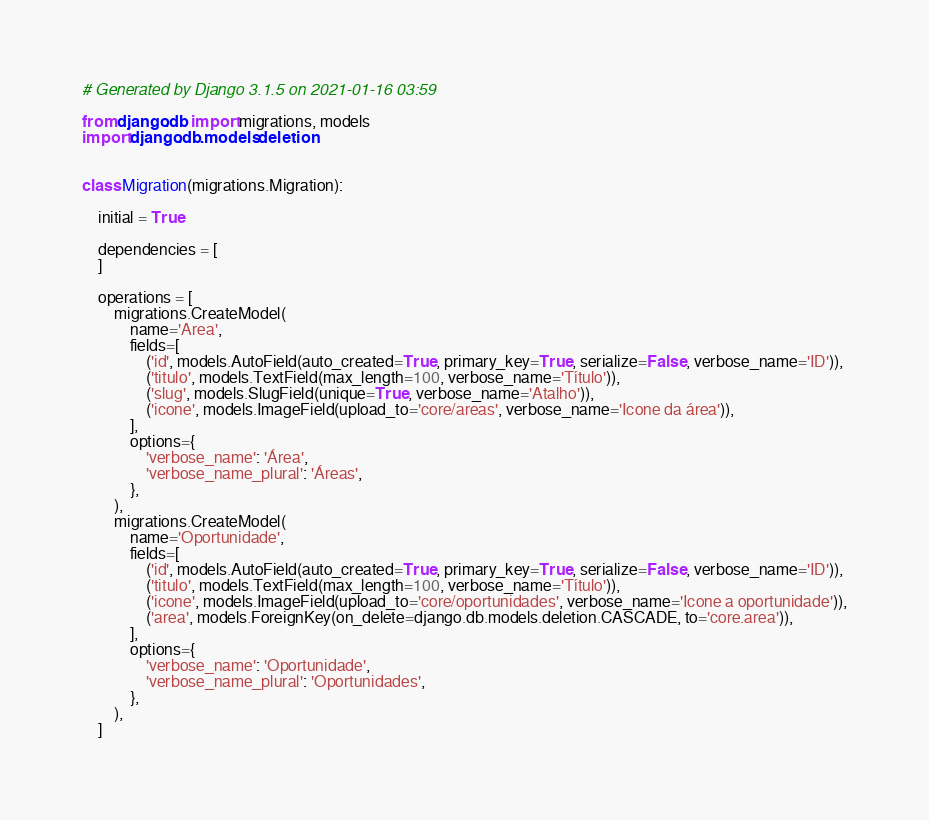<code> <loc_0><loc_0><loc_500><loc_500><_Python_># Generated by Django 3.1.5 on 2021-01-16 03:59

from django.db import migrations, models
import django.db.models.deletion


class Migration(migrations.Migration):

    initial = True

    dependencies = [
    ]

    operations = [
        migrations.CreateModel(
            name='Area',
            fields=[
                ('id', models.AutoField(auto_created=True, primary_key=True, serialize=False, verbose_name='ID')),
                ('titulo', models.TextField(max_length=100, verbose_name='Título')),
                ('slug', models.SlugField(unique=True, verbose_name='Atalho')),
                ('icone', models.ImageField(upload_to='core/areas', verbose_name='Icone da área')),
            ],
            options={
                'verbose_name': 'Área',
                'verbose_name_plural': 'Áreas',
            },
        ),
        migrations.CreateModel(
            name='Oportunidade',
            fields=[
                ('id', models.AutoField(auto_created=True, primary_key=True, serialize=False, verbose_name='ID')),
                ('titulo', models.TextField(max_length=100, verbose_name='Título')),
                ('icone', models.ImageField(upload_to='core/oportunidades', verbose_name='Icone a oportunidade')),
                ('area', models.ForeignKey(on_delete=django.db.models.deletion.CASCADE, to='core.area')),
            ],
            options={
                'verbose_name': 'Oportunidade',
                'verbose_name_plural': 'Oportunidades',
            },
        ),
    ]
</code> 